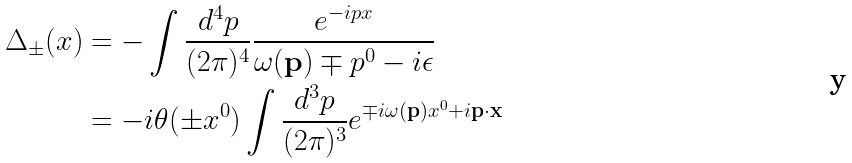<formula> <loc_0><loc_0><loc_500><loc_500>\Delta _ { \pm } ( x ) & = - \int \frac { d ^ { 4 } p } { ( 2 \pi ) ^ { 4 } } \frac { e ^ { - i p x } } { \omega ( \mathbf p ) \mp p ^ { 0 } - i \epsilon } \\ & = - i \theta ( \pm x ^ { 0 } ) \int \frac { d ^ { 3 } p } { ( 2 \pi ) ^ { 3 } } e ^ { \mp i \omega ( \mathbf p ) x ^ { 0 } + i \mathbf p \cdot \mathbf x }</formula> 